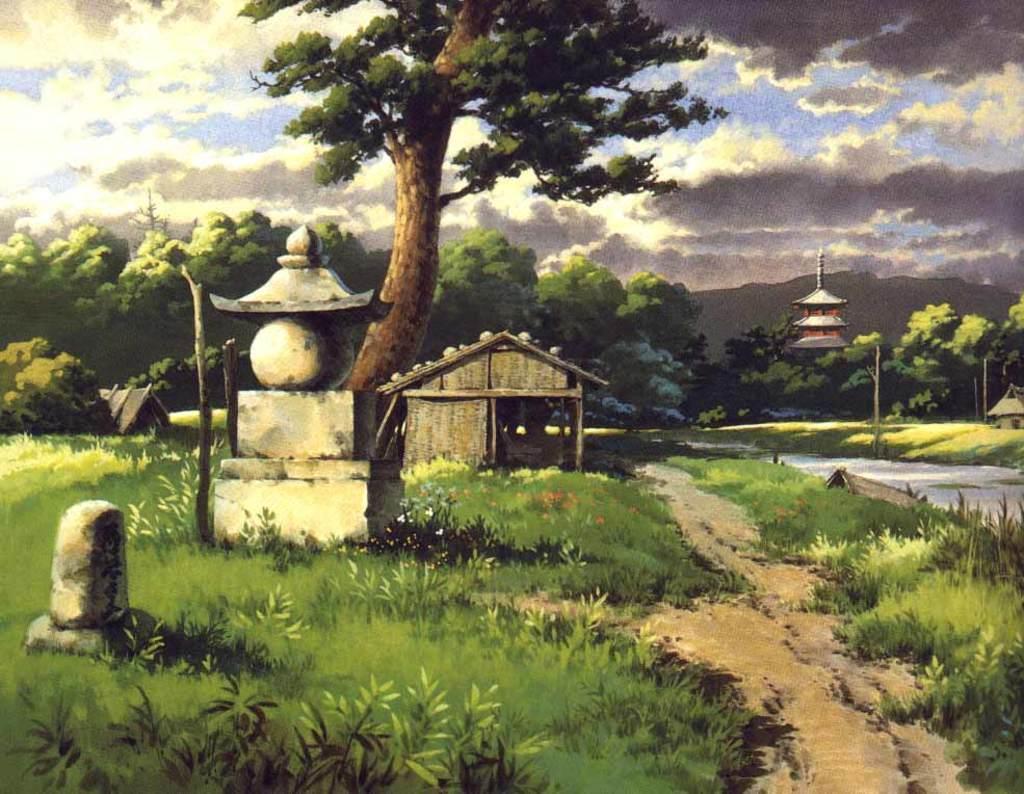How would you summarize this image in a sentence or two? In front of the image there are plants. At the bottom of the image there is grass on the surface. On the left side of the image there are concrete structures. There are wooden poles. In the center of the image there is hut. In the background of the image there is a building. There are trees, mountains and sky. 